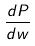Convert formula to latex. <formula><loc_0><loc_0><loc_500><loc_500>\frac { d P } { d w }</formula> 